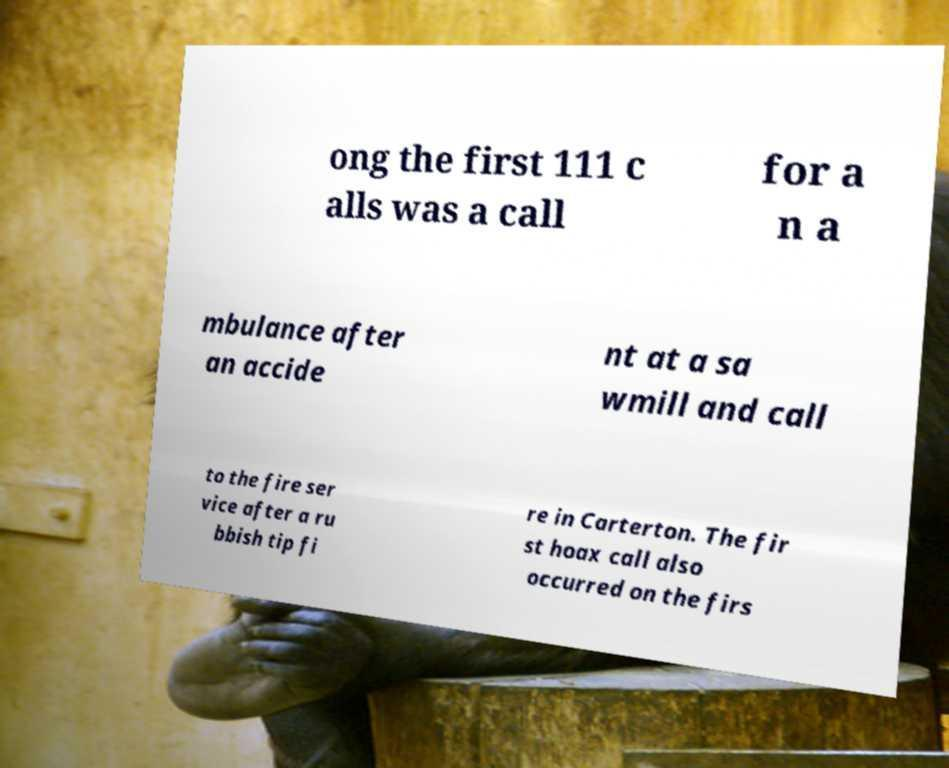Please read and relay the text visible in this image. What does it say? ong the first 111 c alls was a call for a n a mbulance after an accide nt at a sa wmill and call to the fire ser vice after a ru bbish tip fi re in Carterton. The fir st hoax call also occurred on the firs 